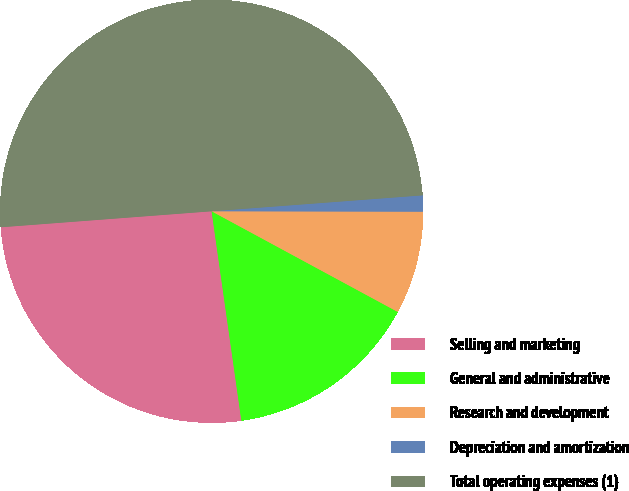Convert chart. <chart><loc_0><loc_0><loc_500><loc_500><pie_chart><fcel>Selling and marketing<fcel>General and administrative<fcel>Research and development<fcel>Depreciation and amortization<fcel>Total operating expenses (1)<nl><fcel>26.04%<fcel>14.86%<fcel>7.86%<fcel>1.23%<fcel>50.0%<nl></chart> 